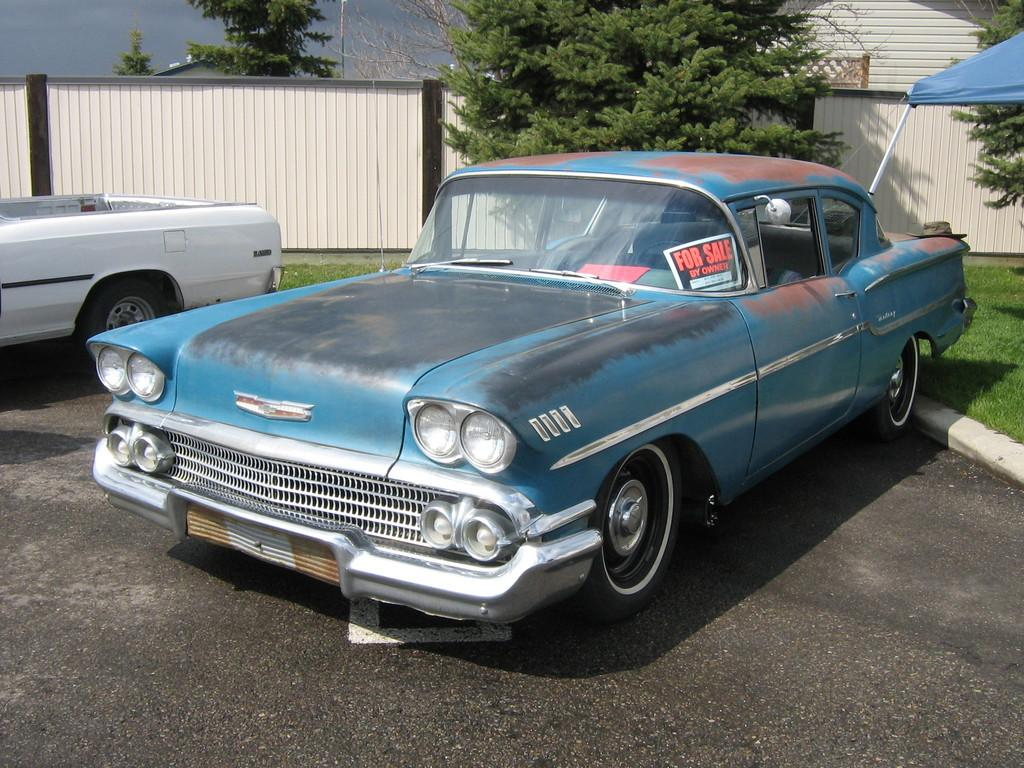What is on the road in the image? There is a vehicle on the road in the image. What type of vegetation can be seen in the image? There is grass and trees visible in the image. What type of structure is present in the image? There is a tent, a wall, and a house in the image. What part of a building is visible in the image? There is a roof in the image. What is visible in the background of the image? The sky is visible in the background of the image. Can you see a pail being used for a game of volleyball in the image? There is no pail or volleyball present in the image. What type of insect can be seen crawling on the roof in the image? There are no insects visible in the image. 